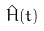Convert formula to latex. <formula><loc_0><loc_0><loc_500><loc_500>\hat { H } ( t )</formula> 